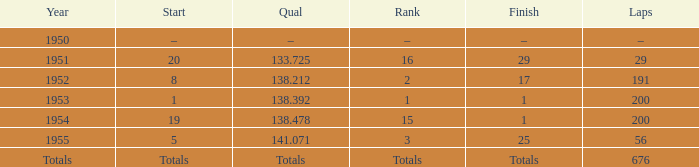How many laps was qualifier of 138.212? 191.0. 